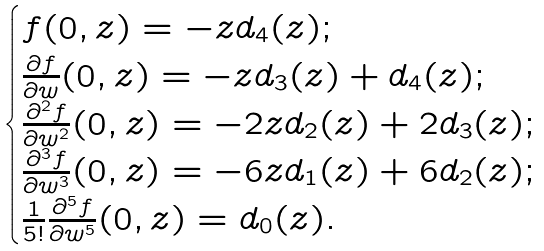Convert formula to latex. <formula><loc_0><loc_0><loc_500><loc_500>\begin{cases} f ( 0 , z ) = - z d _ { 4 } ( z ) ; \\ \frac { \partial f } { \partial w } ( 0 , z ) = - z d _ { 3 } ( z ) + d _ { 4 } ( z ) ; \\ \frac { \partial ^ { 2 } f } { \partial w ^ { 2 } } ( 0 , z ) = - 2 z d _ { 2 } ( z ) + 2 d _ { 3 } ( z ) ; \\ \frac { \partial ^ { 3 } f } { \partial w ^ { 3 } } ( 0 , z ) = - 6 z d _ { 1 } ( z ) + 6 d _ { 2 } ( z ) ; \\ \frac { 1 } { 5 ! } \frac { \partial ^ { 5 } f } { \partial w ^ { 5 } } ( 0 , z ) = d _ { 0 } ( z ) . \end{cases}</formula> 